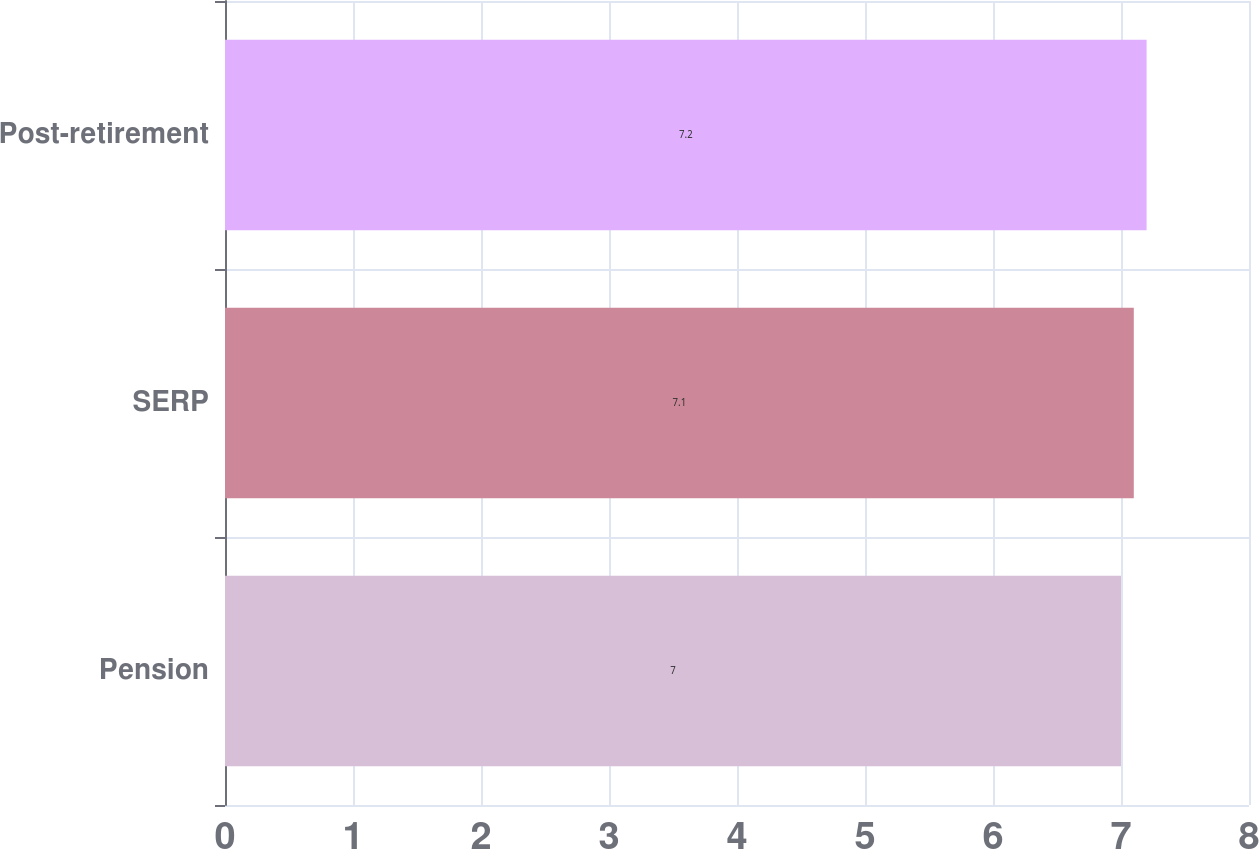<chart> <loc_0><loc_0><loc_500><loc_500><bar_chart><fcel>Pension<fcel>SERP<fcel>Post-retirement<nl><fcel>7<fcel>7.1<fcel>7.2<nl></chart> 